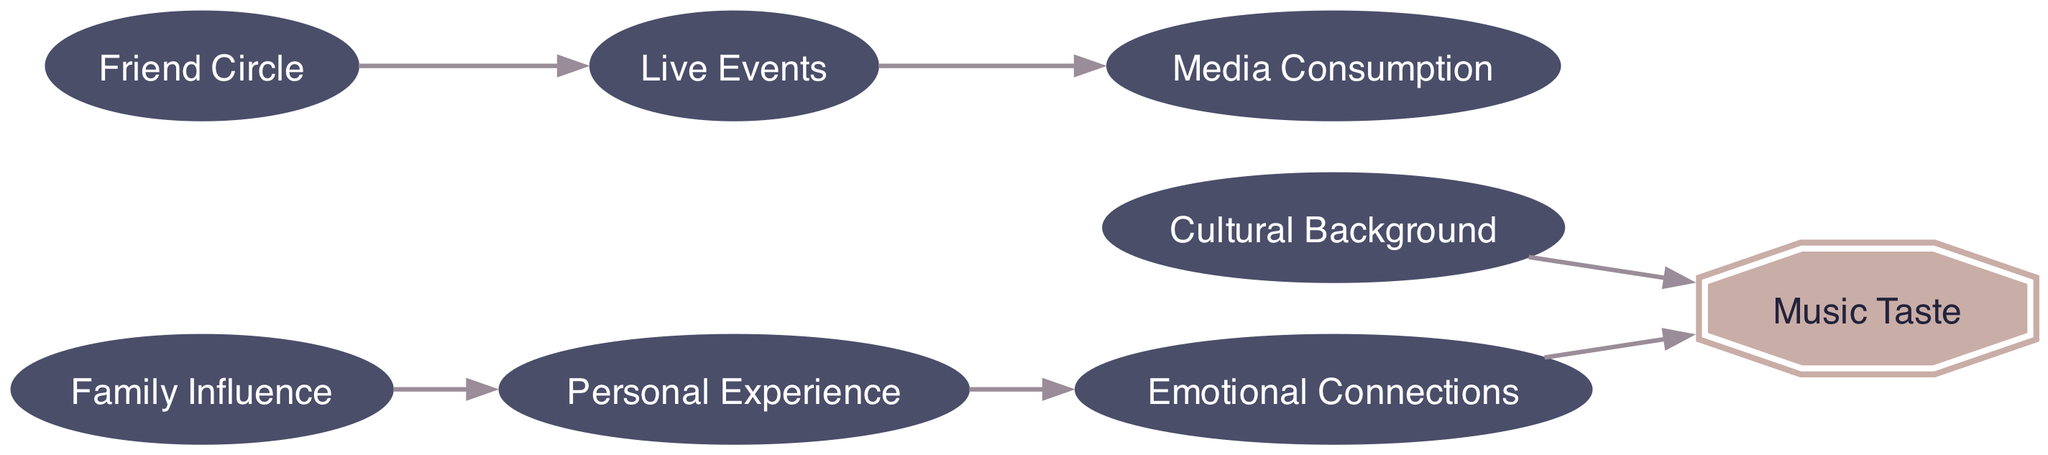What is the total number of nodes in the diagram? The diagram includes a list of nodes, which are Personal Experience, Family Influence, Friend Circle, Live Events, Cultural Background, Media Consumption, Emotional Connections, and Music Taste. Counting these, we find a total of 8 nodes.
Answer: 8 Which node directly influences Emotional Connections? Looking at the edges leading to Emotional Connections, we see that the only direct influencer is Personal Experience.
Answer: Personal Experience What are the two nodes that impact Music Taste directly? By examining the edges that lead into Music Taste, we identify Emotional Connections and Cultural Background as the nodes that directly influence it.
Answer: Emotional Connections, Cultural Background How many edges point to Media Consumption? From the diagram, we can see that there is only one node, Live Events, that has an edge directed toward Media Consumption.
Answer: 1 Which node influences Live Events? The Friend Circle node has a direct edge that points to Live Events, indicating that the Friend Circle has an influence on it.
Answer: Friend Circle If Personal Experience is affected by Family Influence, what is the path to Music Taste through these nodes? The path begins at Family Influence, which points to Personal Experience, then Personal Experience affects Emotional Connections, and finally, Emotional Connections lead to Music Taste. Thus, the path is Family Influence -> Personal Experience -> Emotional Connections -> Music Taste.
Answer: Family Influence -> Personal Experience -> Emotional Connections -> Music Taste What is the relationship between Live Events and Media Consumption? The Live Events node has a directed edge leading to the Media Consumption node, indicating that Live Events influences Media Consumption.
Answer: Live Events influences Media Consumption Which two nodes come before Emotional Connections in the directed graph? To find the nodes that lead into Emotional Connections, we look at the directed edges. The source node is Personal Experience. Thus, the answer is that Personal Experience is the only node that comes before Emotional Connections.
Answer: Personal Experience 